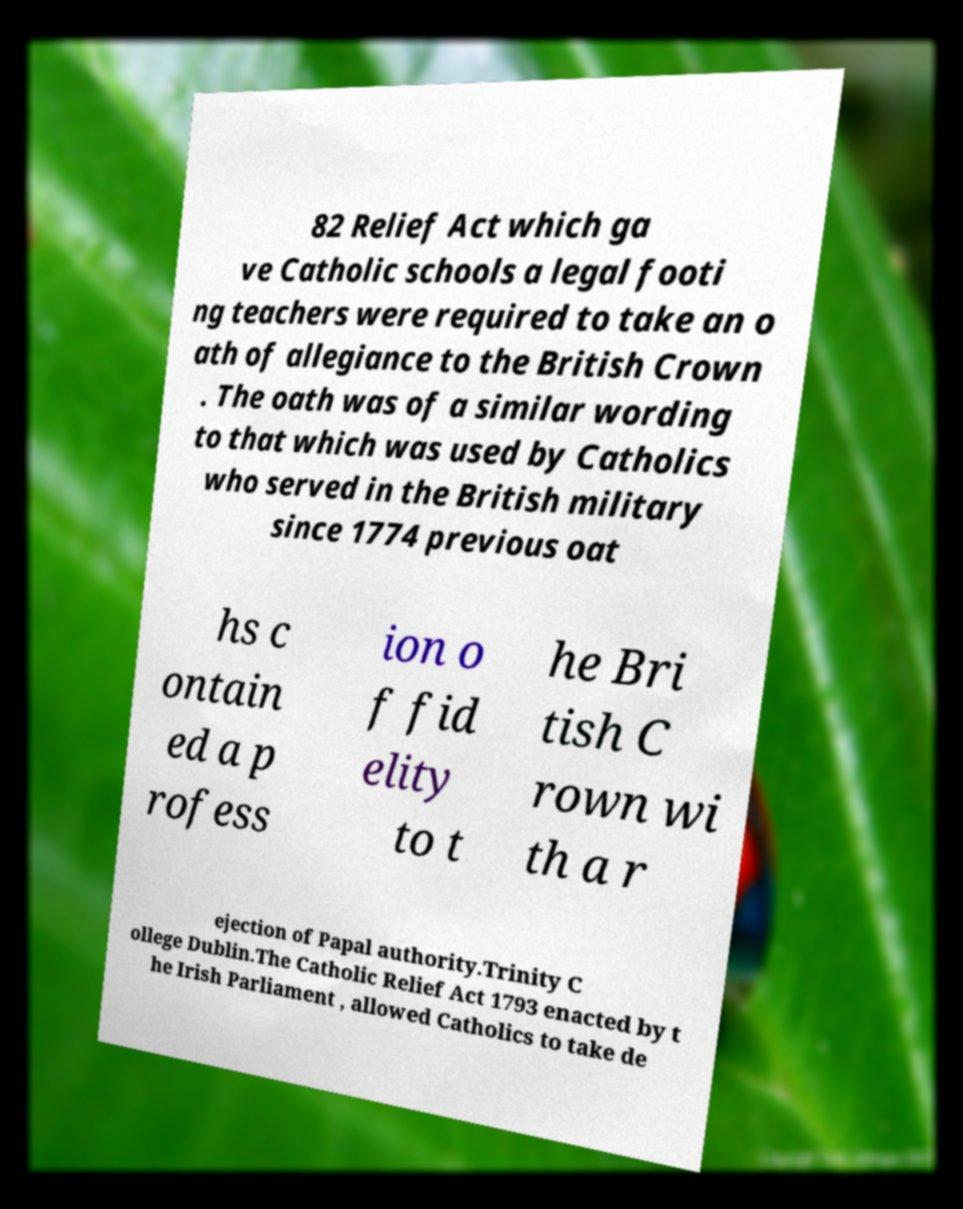Could you assist in decoding the text presented in this image and type it out clearly? 82 Relief Act which ga ve Catholic schools a legal footi ng teachers were required to take an o ath of allegiance to the British Crown . The oath was of a similar wording to that which was used by Catholics who served in the British military since 1774 previous oat hs c ontain ed a p rofess ion o f fid elity to t he Bri tish C rown wi th a r ejection of Papal authority.Trinity C ollege Dublin.The Catholic Relief Act 1793 enacted by t he Irish Parliament , allowed Catholics to take de 